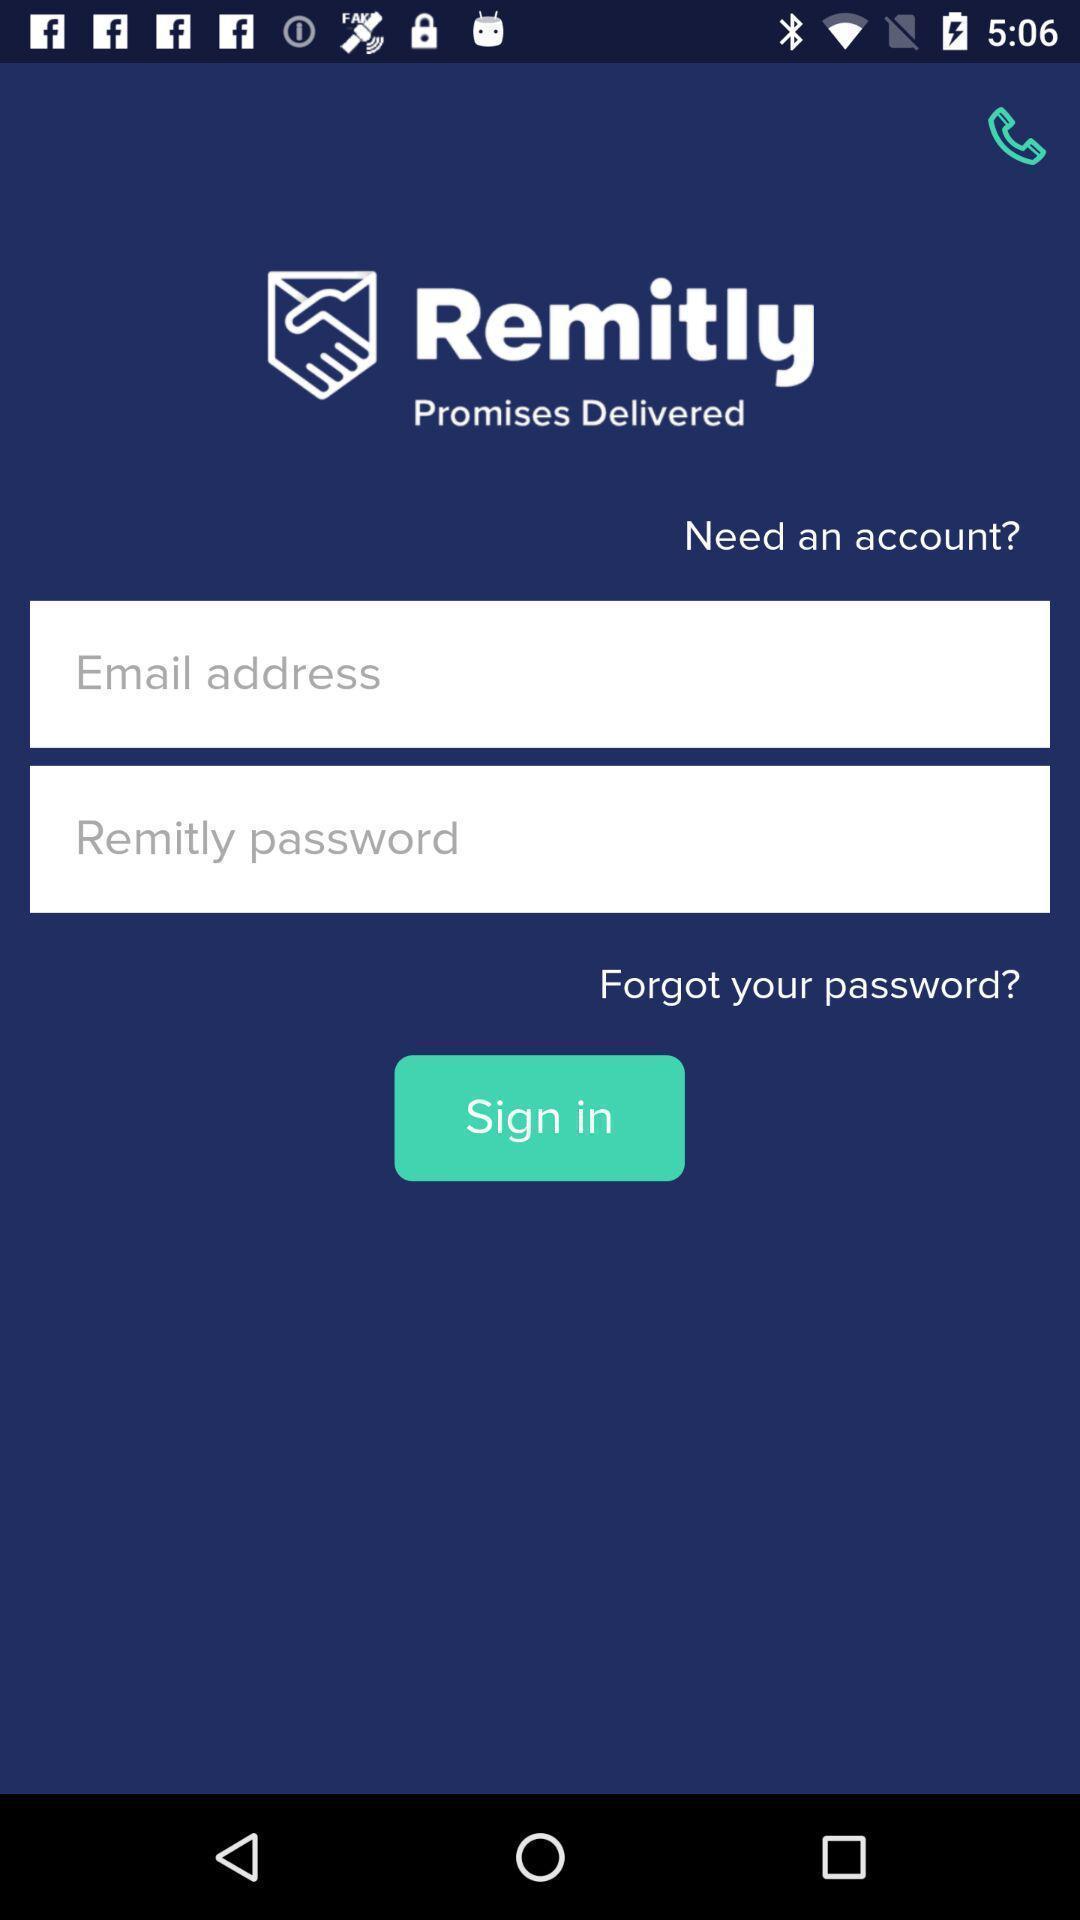Summarize the information in this screenshot. Sign in page. 